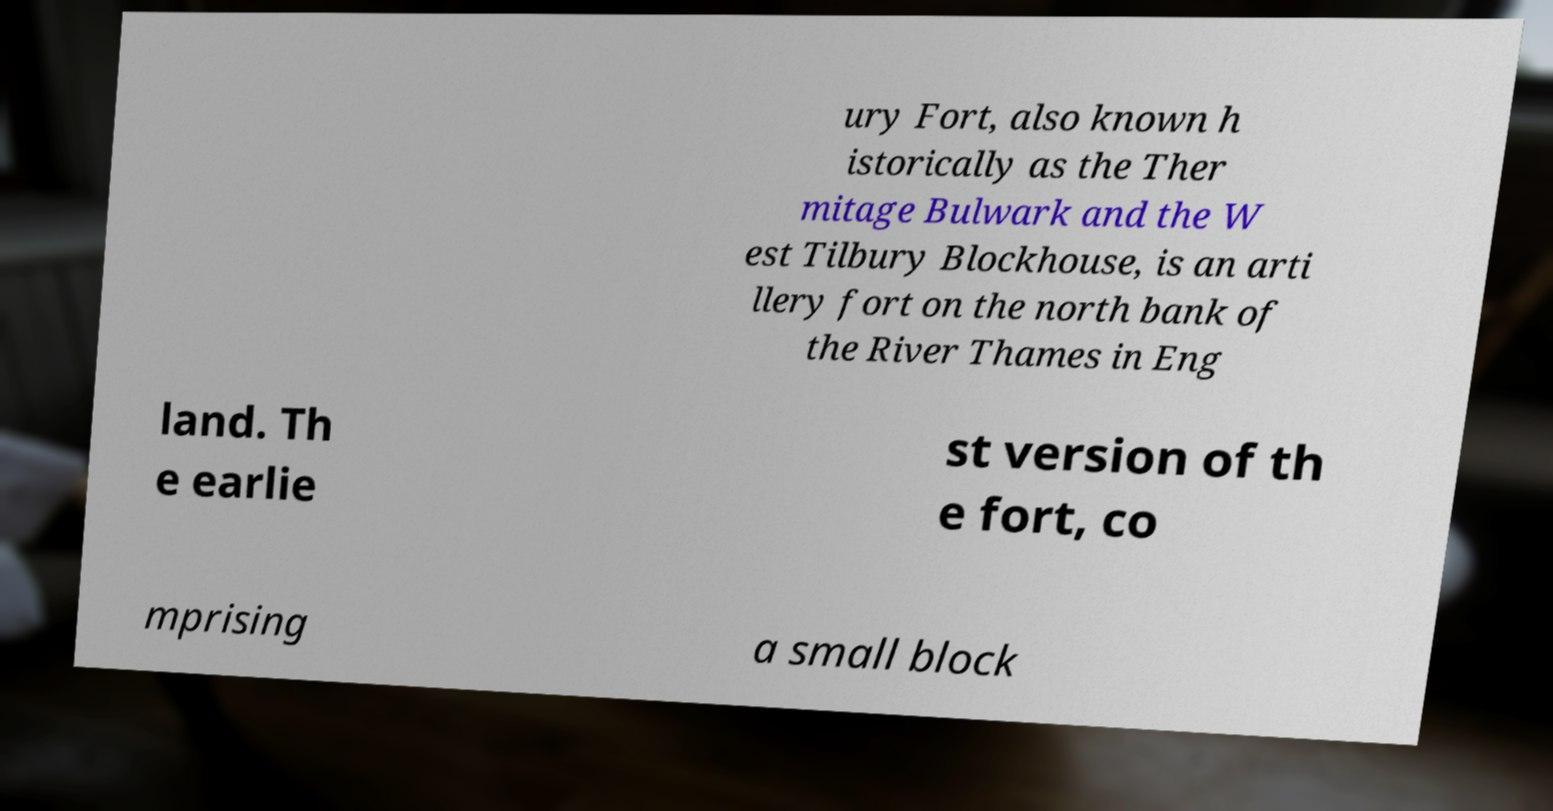Can you read and provide the text displayed in the image?This photo seems to have some interesting text. Can you extract and type it out for me? ury Fort, also known h istorically as the Ther mitage Bulwark and the W est Tilbury Blockhouse, is an arti llery fort on the north bank of the River Thames in Eng land. Th e earlie st version of th e fort, co mprising a small block 